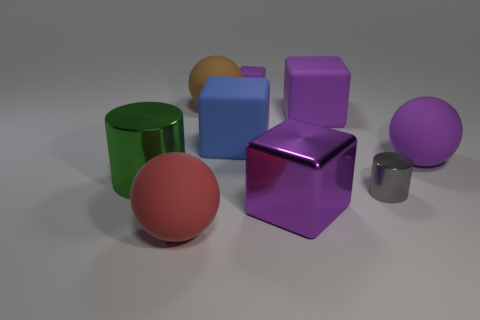Are there the same number of tiny gray metal cylinders to the left of the big blue matte object and big cubes?
Make the answer very short. No. How many big spheres are to the right of the large blue thing and behind the blue rubber block?
Ensure brevity in your answer.  0. The blue cube that is the same material as the red sphere is what size?
Make the answer very short. Large. How many brown rubber things have the same shape as the gray shiny thing?
Your response must be concise. 0. Is the number of green objects left of the large red sphere greater than the number of tiny yellow spheres?
Your response must be concise. Yes. What shape is the large object that is both behind the big purple metallic block and on the left side of the brown thing?
Your answer should be compact. Cylinder. Does the green metallic thing have the same size as the purple metallic block?
Provide a short and direct response. Yes. What number of tiny cylinders are to the left of the big purple shiny block?
Provide a succinct answer. 0. Is the number of big brown rubber balls that are in front of the large blue matte cube the same as the number of big balls in front of the large green shiny cylinder?
Provide a short and direct response. No. There is a purple matte thing right of the gray cylinder; does it have the same shape as the gray shiny object?
Keep it short and to the point. No. 